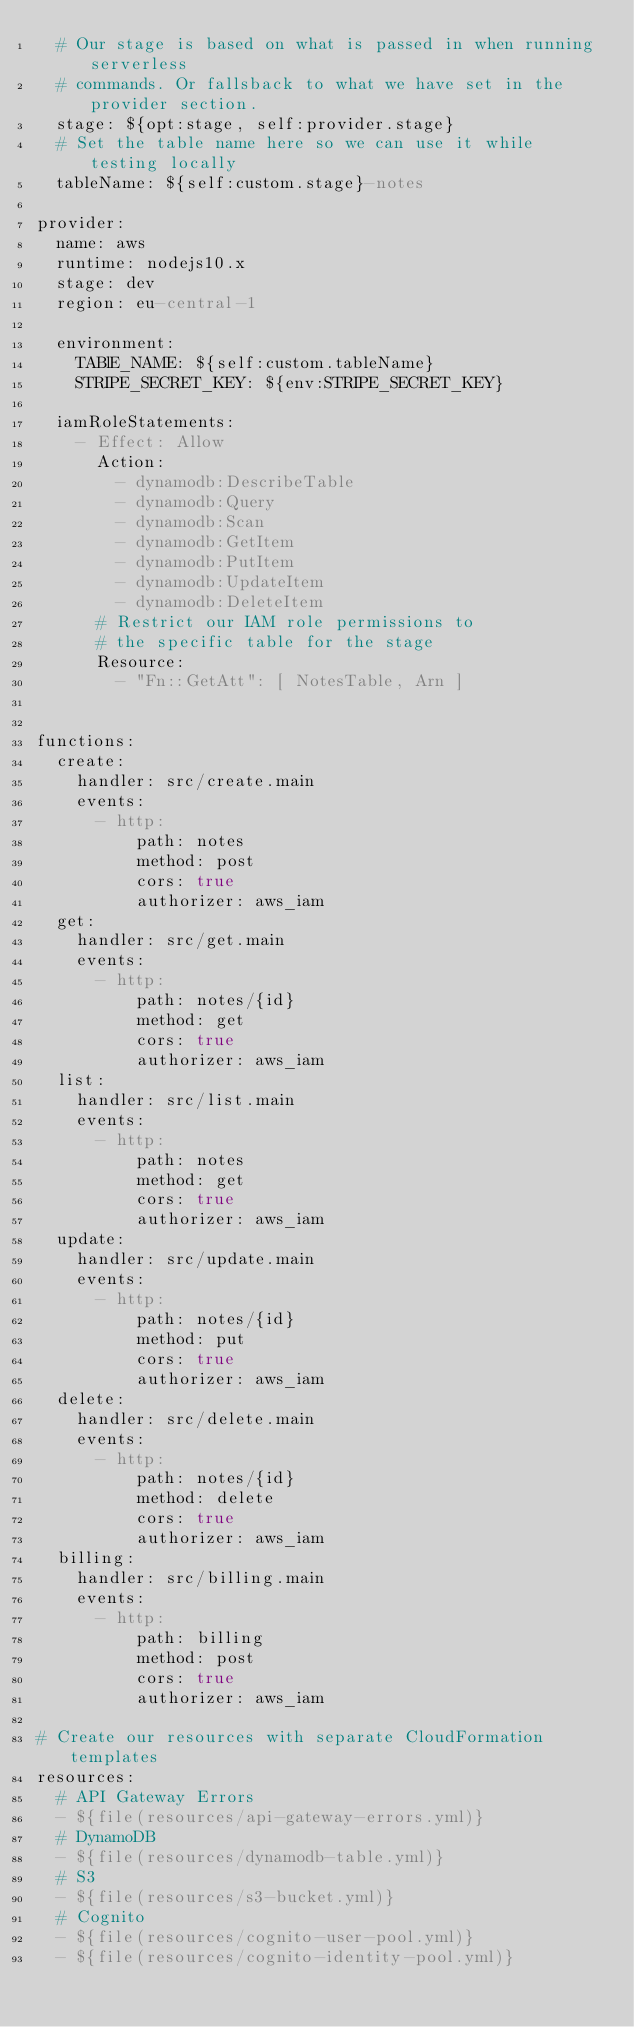Convert code to text. <code><loc_0><loc_0><loc_500><loc_500><_YAML_>  # Our stage is based on what is passed in when running serverless
  # commands. Or fallsback to what we have set in the provider section.
  stage: ${opt:stage, self:provider.stage}
  # Set the table name here so we can use it while testing locally
  tableName: ${self:custom.stage}-notes

provider:
  name: aws
  runtime: nodejs10.x
  stage: dev
  region: eu-central-1

  environment:
    TABlE_NAME: ${self:custom.tableName}
    STRIPE_SECRET_KEY: ${env:STRIPE_SECRET_KEY}

  iamRoleStatements:
    - Effect: Allow
      Action:
        - dynamodb:DescribeTable
        - dynamodb:Query
        - dynamodb:Scan
        - dynamodb:GetItem
        - dynamodb:PutItem
        - dynamodb:UpdateItem
        - dynamodb:DeleteItem
      # Restrict our IAM role permissions to
      # the specific table for the stage
      Resource:
        - "Fn::GetAtt": [ NotesTable, Arn ]


functions:
  create:
    handler: src/create.main
    events:
      - http:
          path: notes
          method: post
          cors: true
          authorizer: aws_iam
  get:
    handler: src/get.main
    events:
      - http:
          path: notes/{id}
          method: get
          cors: true
          authorizer: aws_iam
  list:
    handler: src/list.main
    events:
      - http:
          path: notes
          method: get
          cors: true
          authorizer: aws_iam
  update:
    handler: src/update.main
    events:
      - http:
          path: notes/{id}
          method: put
          cors: true
          authorizer: aws_iam
  delete:
    handler: src/delete.main
    events:
      - http:
          path: notes/{id}
          method: delete
          cors: true
          authorizer: aws_iam
  billing:
    handler: src/billing.main
    events:
      - http:
          path: billing
          method: post
          cors: true
          authorizer: aws_iam

# Create our resources with separate CloudFormation templates
resources:
  # API Gateway Errors
  - ${file(resources/api-gateway-errors.yml)}
  # DynamoDB
  - ${file(resources/dynamodb-table.yml)}
  # S3
  - ${file(resources/s3-bucket.yml)}
  # Cognito
  - ${file(resources/cognito-user-pool.yml)}
  - ${file(resources/cognito-identity-pool.yml)}

</code> 